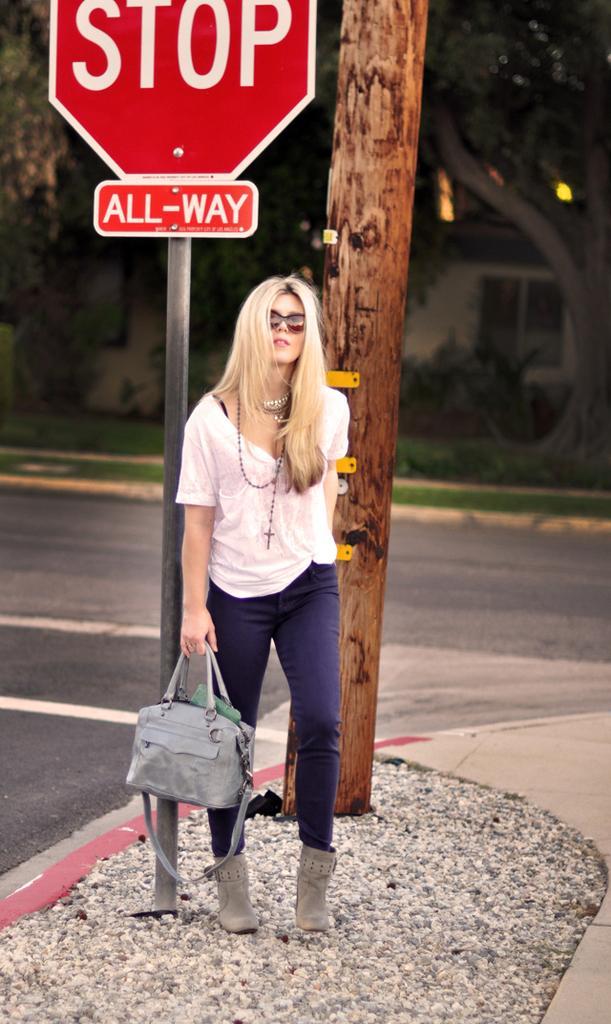How would you summarize this image in a sentence or two? On the background we can see a house with window, plants and trees and fresh green grass. This is a road. This is a branch. We can see a sign board here "stop all- way". We can see one women standing beside this sign board holding a handbag on her hand. She wore goggles. 